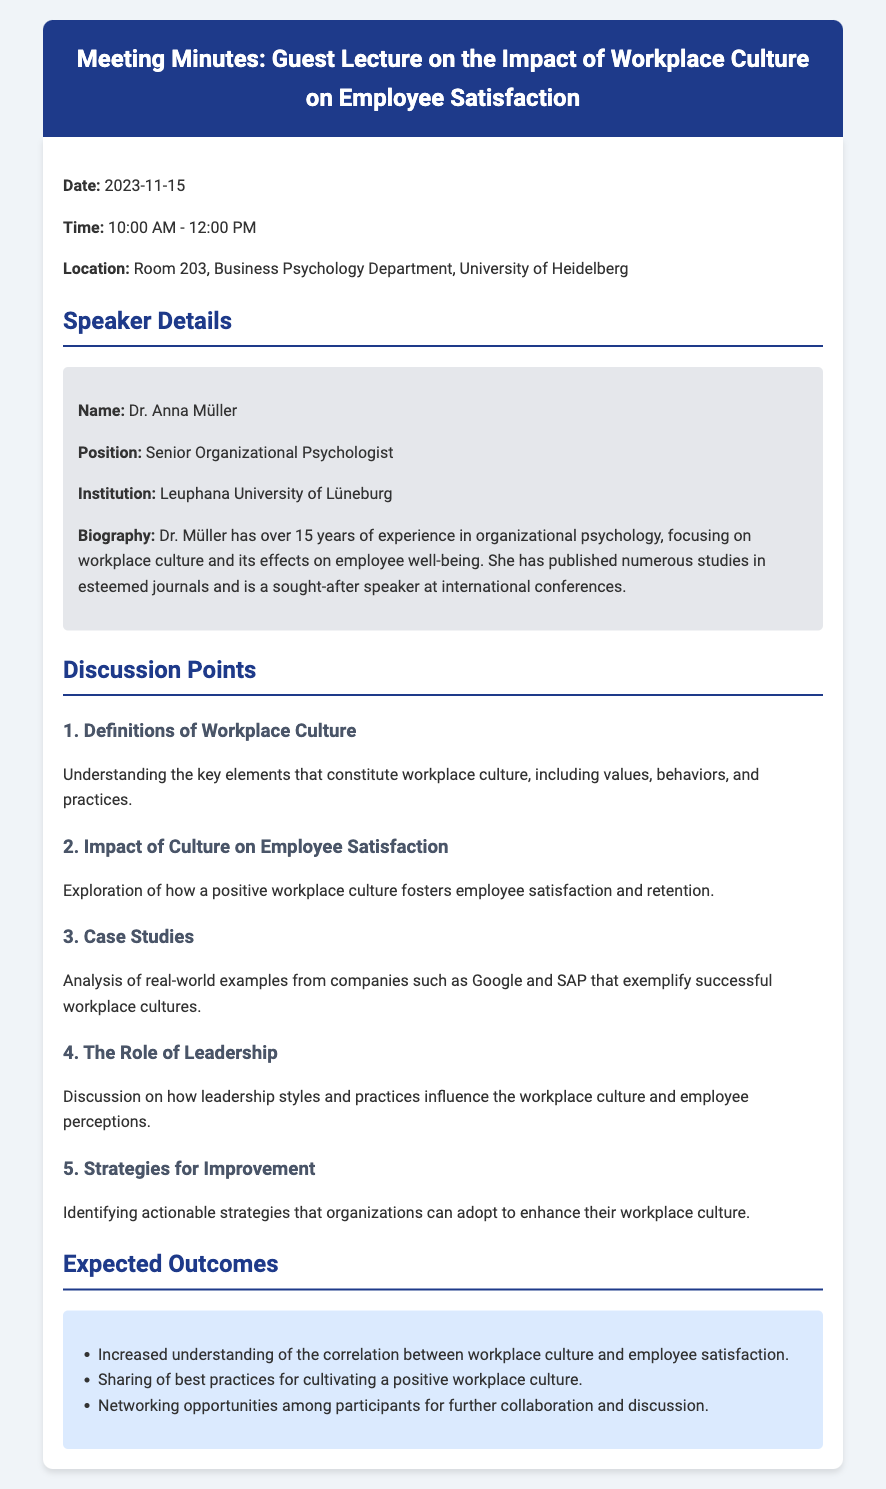What is the date of the meeting? The meeting is scheduled for November 15, 2023.
Answer: November 15, 2023 Who is the speaker? The document states that Dr. Anna Müller is the speaker.
Answer: Dr. Anna Müller What is Dr. Müller's position? The speaker's position is listed as Senior Organizational Psychologist.
Answer: Senior Organizational Psychologist What university is Dr. Müller affiliated with? The document mentions that Dr. Müller works at Leuphana University of Lüneburg.
Answer: Leuphana University of Lüneburg What is one of the discussion points? The document lists several discussion points, including definitions of workplace culture.
Answer: Definitions of Workplace Culture How long has Dr. Müller been working in organizational psychology? The document indicates that Dr. Müller has over 15 years of experience in her field.
Answer: Over 15 years What are expected outcomes of the meeting? One of the expected outcomes includes increased understanding of the correlation between workplace culture and employee satisfaction.
Answer: Increased understanding of the correlation between workplace culture and employee satisfaction Where is the meeting taking place? According to the document, the meeting is in Room 203, Business Psychology Department, University of Heidelberg.
Answer: Room 203, Business Psychology Department, University of Heidelberg What case studies will be discussed? The document mentions real-world examples from companies such as Google and SAP.
Answer: Google and SAP 